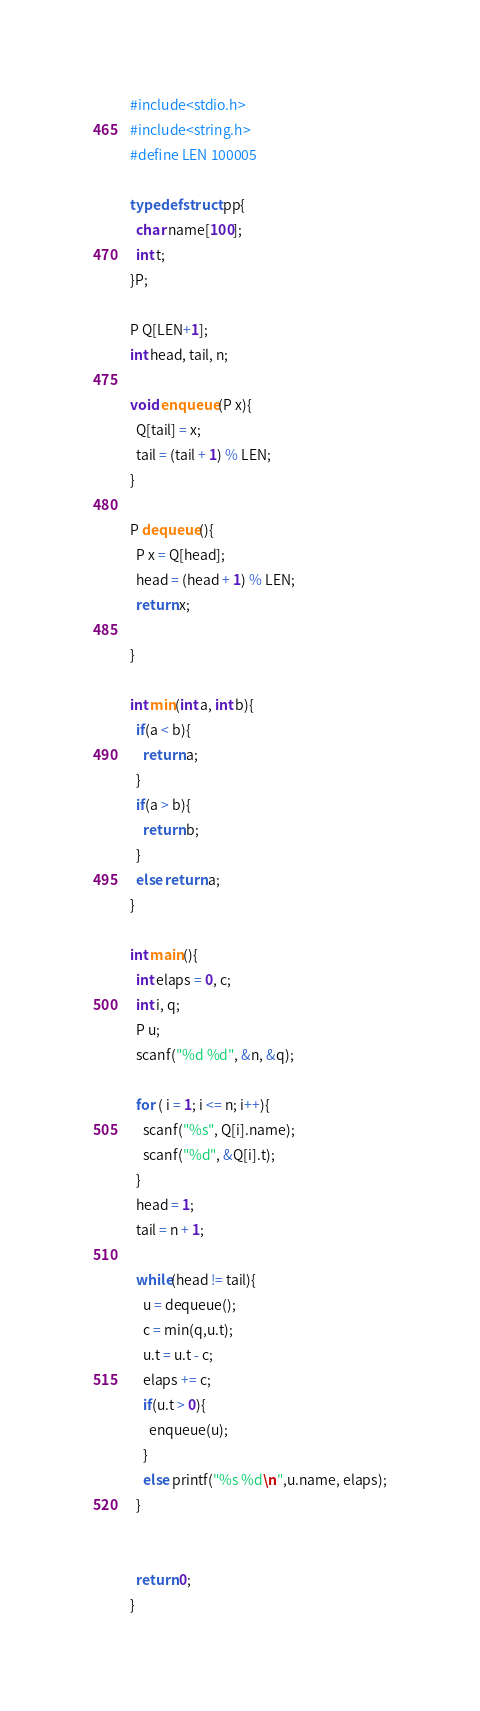<code> <loc_0><loc_0><loc_500><loc_500><_C_>#include<stdio.h>
#include<string.h>
#define LEN 100005

typedef struct pp{
  char name[100];
  int t;
}P;

P Q[LEN+1];
int head, tail, n;

void enqueue(P x){
  Q[tail] = x;
  tail = (tail + 1) % LEN;
}

P dequeue(){
  P x = Q[head];
  head = (head + 1) % LEN;
  return x;

}

int min(int a, int b){
  if(a < b){
    return a;
  }
  if(a > b){
    return b;
  }
  else return a;
}

int main(){
  int elaps = 0, c;
  int i, q;
  P u;
  scanf("%d %d", &n, &q);

  for ( i = 1; i <= n; i++){
    scanf("%s", Q[i].name);
    scanf("%d", &Q[i].t);
  }
  head = 1;
  tail = n + 1;

  while(head != tail){
    u = dequeue();
    c = min(q,u.t);
    u.t = u.t - c;
    elaps += c;
    if(u.t > 0){
      enqueue(u);
    }
    else printf("%s %d\n",u.name, elaps);
  }
  
  
  return 0;
}

</code> 